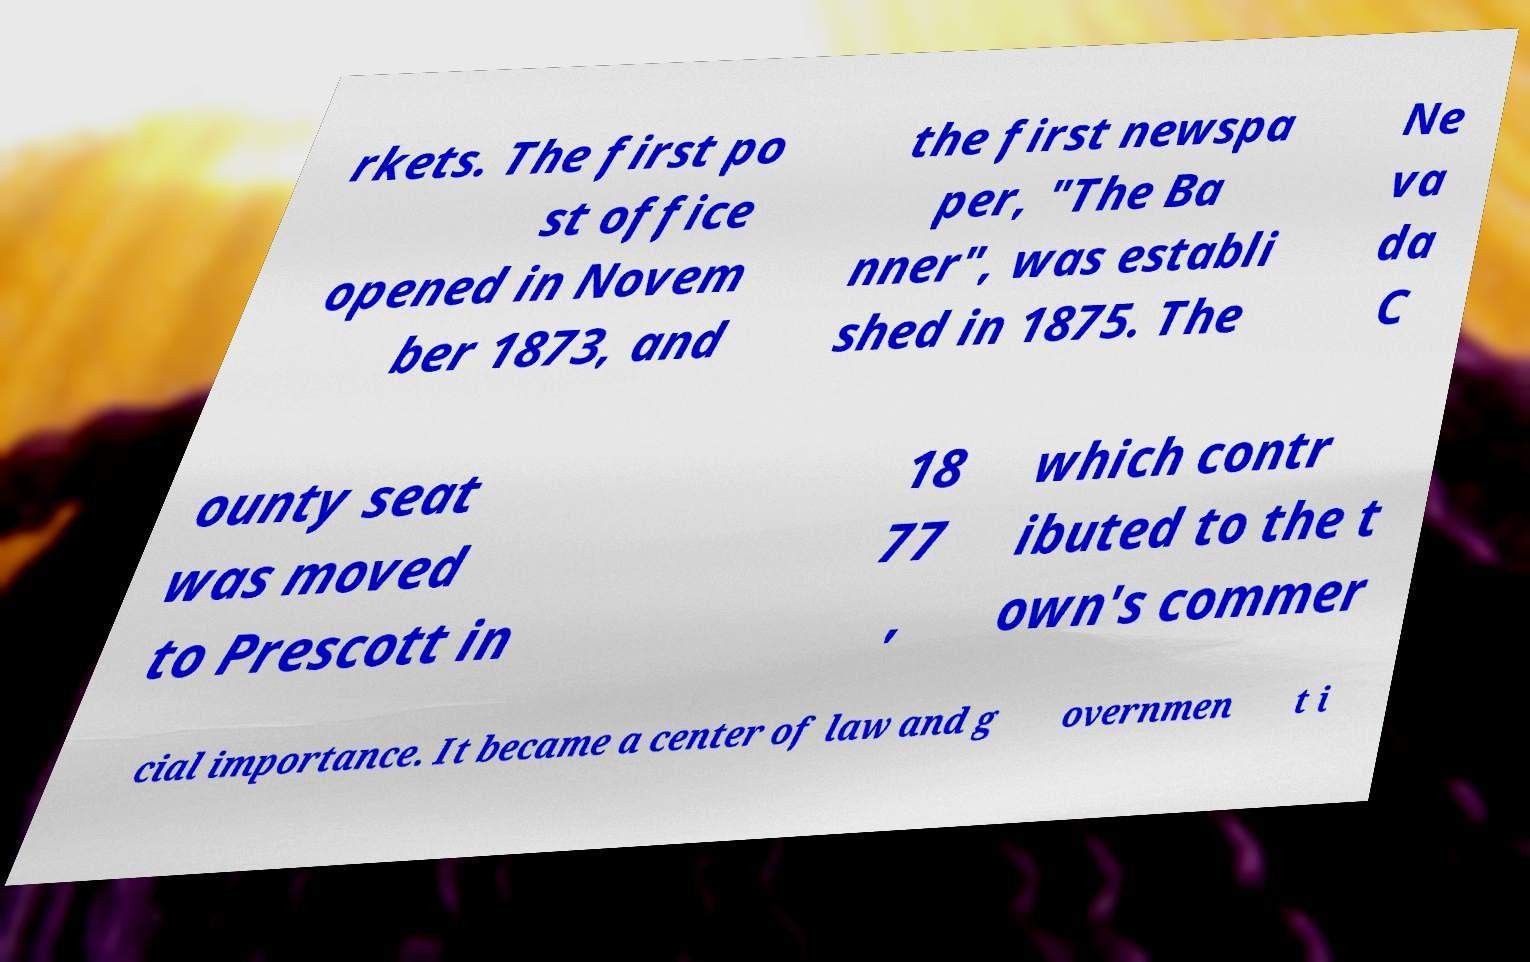For documentation purposes, I need the text within this image transcribed. Could you provide that? rkets. The first po st office opened in Novem ber 1873, and the first newspa per, "The Ba nner", was establi shed in 1875. The Ne va da C ounty seat was moved to Prescott in 18 77 , which contr ibuted to the t own's commer cial importance. It became a center of law and g overnmen t i 